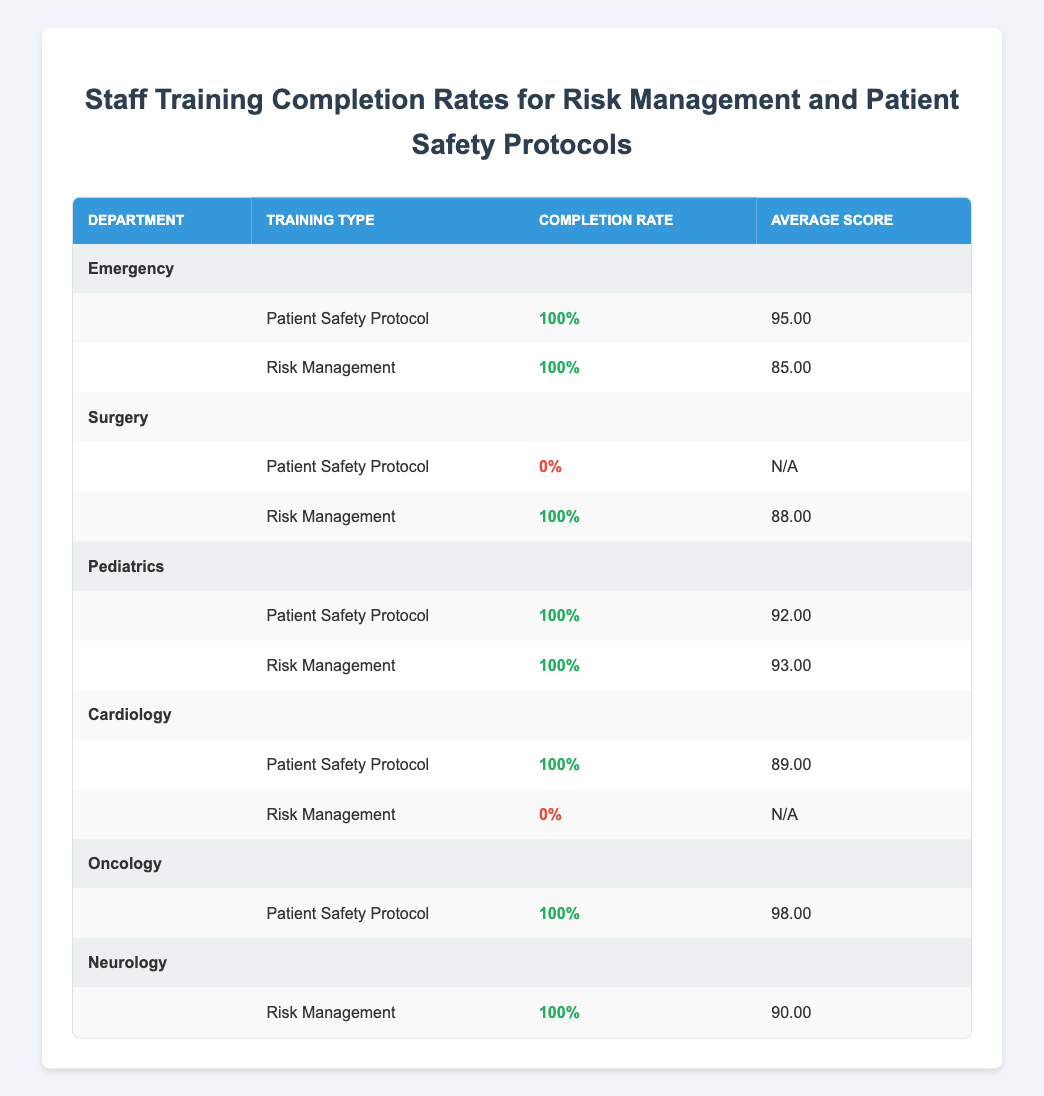What's the completion rate for the Emergency department's Patient Safety Protocol training? According to the table, the completion rate for the Emergency department's Patient Safety Protocol training is shown as 100%.
Answer: 100% How many staff members completed the Risk Management training in the Surgery department? The table lists one staff member, Dr. Michael Chen, who completed the Risk Management training. Other staff members in this department have incomplete training.
Answer: 1 Which department has the highest average score for the Patient Safety Protocol training? From the table, the average scores are: Emergency (95), Pediatrics (92), Cardiology (89), and Oncology (98). Thus, Oncology has the highest average score.
Answer: Oncology Is there any department where the Risk Management training has a completion rate of 0%? Yes, the Surgery department's Patient Safety Protocol training has a completion rate of 0% as displayed in the table; it lists no completed training for that type.
Answer: Yes What is the overall average score for completed Risk Management trainings across all departments? The completed Risk Management trainings have scores of: 88 (Surgery), 93 (Pediatrics), 90 (Neurology), and 85 (Emergency). Summing these (88 + 93 + 90 + 85 = 356) and dividing by 4 gives an average of 89.
Answer: 89 Which department has the most staff trained in Patient Safety Protocols and what is their completion rate? The table shows that all departments listed trained in Patient Safety Protocol, with each department (Emergency, Pediatrics, Cardiology, and Oncology) demonstrating a completion rate of 100%. Both Emergency and Oncology have staff trained, suggesting either of these has the most.
Answer: 100% What percentage of staff completed the entire Risk Management training program across all departments? The Risk Management training has completed entries from Surgery (1), Pediatrics (1), Neurology (1), and Emergency (1) but misses entries for Cardiology. Total completed across departments is 4 of 5 who were supposed to attend, gives 80% overall completion rate for Risk Management training.
Answer: 80% Has any staff received an average score below 90 in the completed training for Risk Management? In the table, Emergency and Surgery departments show scores of 85 and 88, respectively. Thus, both had below 90, indicating that at least some staff scored below this threshold.
Answer: Yes Explain how many departments have both types of training with a completion rate of 100%? Checking the table, the departments Emergency, Pediatrics, and Oncology have both a completion rate of 100% in their training programs for both Patient Safety and Risk Management protocols. Thus, there are three departments with fully completed training for both types.
Answer: 3 